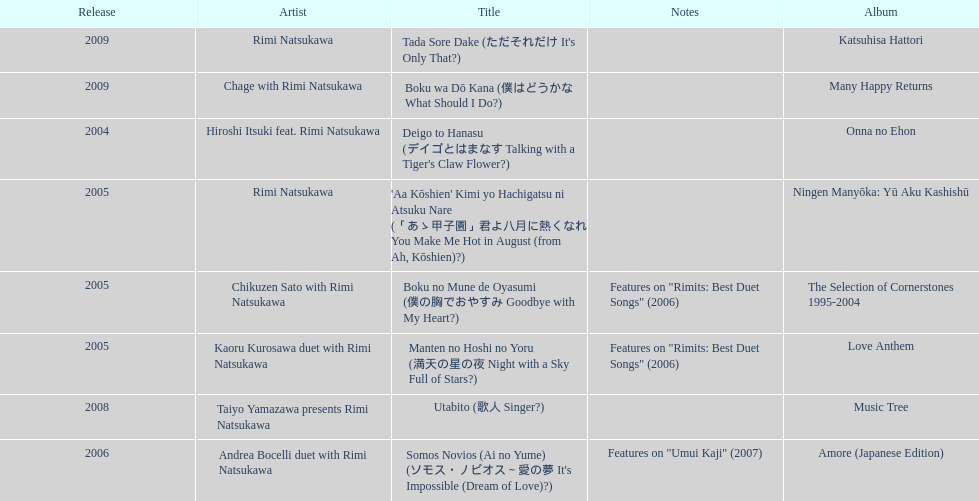Which was not released in 2004, onna no ehon or music tree? Music Tree. Write the full table. {'header': ['Release', 'Artist', 'Title', 'Notes', 'Album'], 'rows': [['2009', 'Rimi Natsukawa', "Tada Sore Dake (ただそれだけ It's Only That?)", '', 'Katsuhisa Hattori'], ['2009', 'Chage with Rimi Natsukawa', 'Boku wa Dō Kana (僕はどうかな What Should I Do?)', '', 'Many Happy Returns'], ['2004', 'Hiroshi Itsuki feat. Rimi Natsukawa', "Deigo to Hanasu (デイゴとはまなす Talking with a Tiger's Claw Flower?)", '', 'Onna no Ehon'], ['2005', 'Rimi Natsukawa', "'Aa Kōshien' Kimi yo Hachigatsu ni Atsuku Nare (「あゝ甲子園」君よ八月に熱くなれ You Make Me Hot in August (from Ah, Kōshien)?)", '', 'Ningen Manyōka: Yū Aku Kashishū'], ['2005', 'Chikuzen Sato with Rimi Natsukawa', 'Boku no Mune de Oyasumi (僕の胸でおやすみ Goodbye with My Heart?)', 'Features on "Rimits: Best Duet Songs" (2006)', 'The Selection of Cornerstones 1995-2004'], ['2005', 'Kaoru Kurosawa duet with Rimi Natsukawa', 'Manten no Hoshi no Yoru (満天の星の夜 Night with a Sky Full of Stars?)', 'Features on "Rimits: Best Duet Songs" (2006)', 'Love Anthem'], ['2008', 'Taiyo Yamazawa presents Rimi Natsukawa', 'Utabito (歌人 Singer?)', '', 'Music Tree'], ['2006', 'Andrea Bocelli duet with Rimi Natsukawa', "Somos Novios (Ai no Yume) (ソモス・ノビオス～愛の夢 It's Impossible (Dream of Love)?)", 'Features on "Umui Kaji" (2007)', 'Amore (Japanese Edition)']]} 